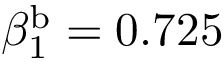Convert formula to latex. <formula><loc_0><loc_0><loc_500><loc_500>\beta _ { 1 } ^ { b } = 0 . 7 2 5</formula> 